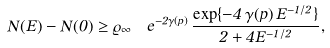Convert formula to latex. <formula><loc_0><loc_0><loc_500><loc_500>N ( E ) - N ( 0 ) \geq \varrho _ { \infty } \, \ e ^ { - 2 \gamma ( p ) } \, \frac { \exp \{ - 4 \, \gamma ( p ) \, E ^ { - 1 / 2 } \} } { 2 + 4 E ^ { - 1 / 2 } } ,</formula> 